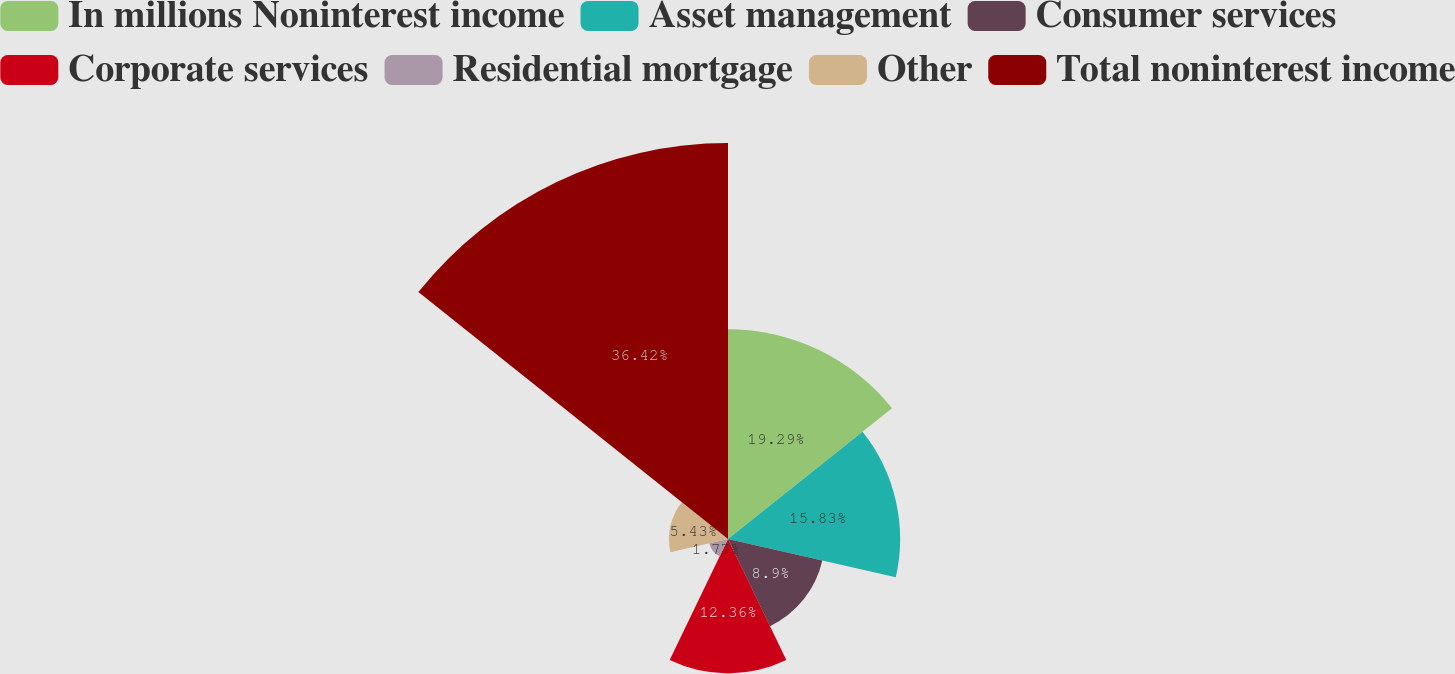<chart> <loc_0><loc_0><loc_500><loc_500><pie_chart><fcel>In millions Noninterest income<fcel>Asset management<fcel>Consumer services<fcel>Corporate services<fcel>Residential mortgage<fcel>Other<fcel>Total noninterest income<nl><fcel>19.29%<fcel>15.83%<fcel>8.9%<fcel>12.36%<fcel>1.77%<fcel>5.43%<fcel>36.42%<nl></chart> 